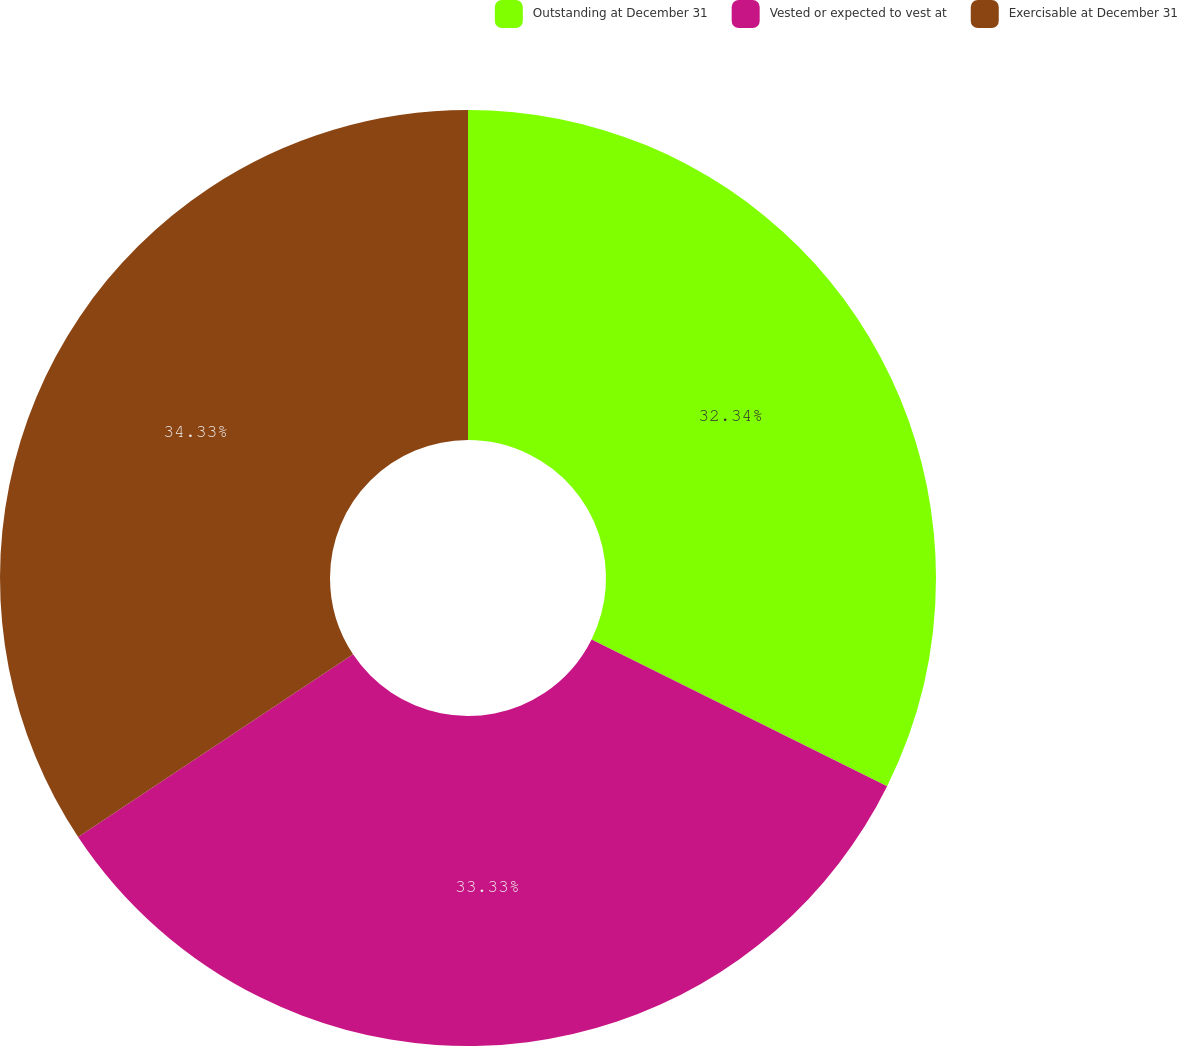<chart> <loc_0><loc_0><loc_500><loc_500><pie_chart><fcel>Outstanding at December 31<fcel>Vested or expected to vest at<fcel>Exercisable at December 31<nl><fcel>32.34%<fcel>33.33%<fcel>34.33%<nl></chart> 